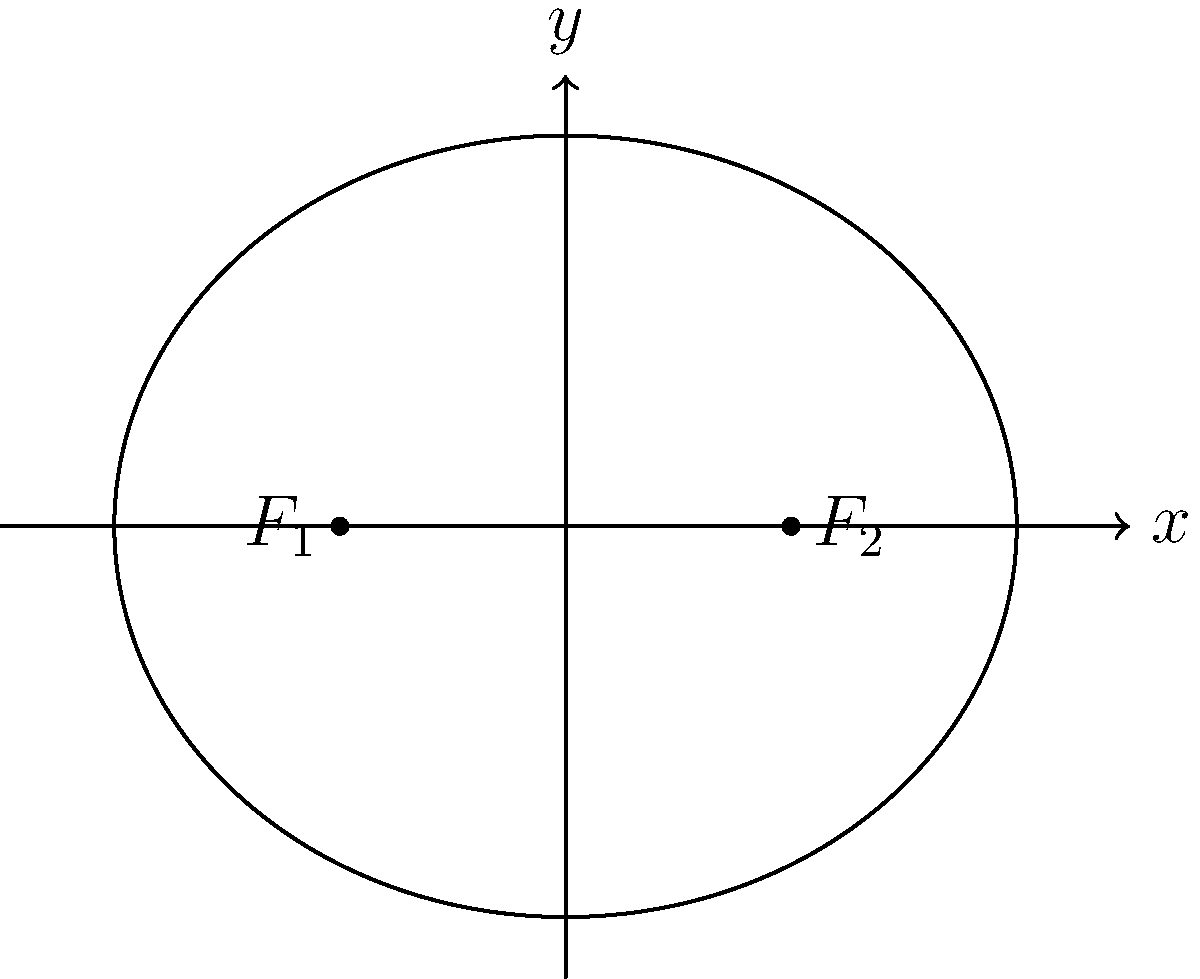As a coordinator for aid distribution, you need to determine the optimal area for distributing supplies. The distribution area is modeled by an ellipse with foci at $(-2,0)$ and $(2,0)$, and a semi-major axis of 4 units. Calculate the area of this elliptical distribution zone to the nearest square unit. To calculate the area of the elliptical distribution zone, we'll follow these steps:

1) The general formula for the area of an ellipse is $A = \pi ab$, where $a$ is the semi-major axis and $b$ is the semi-minor axis.

2) We're given that the semi-major axis $a = 4$.

3) To find $b$, we can use the relationship between the foci, semi-major axis, and semi-minor axis in an ellipse:
   $c^2 = a^2 - b^2$, where $c$ is half the distance between the foci.

4) The distance between the foci is 4 units (from -2 to 2), so $c = 2$.

5) Substituting into the equation:
   $2^2 = 4^2 - b^2$
   $4 = 16 - b^2$
   $b^2 = 12$
   $b = \sqrt{12} = 2\sqrt{3}$

6) Now we can calculate the area:
   $A = \pi ab = \pi \cdot 4 \cdot 2\sqrt{3} = 8\pi\sqrt{3}$

7) To the nearest square unit:
   $8\pi\sqrt{3} \approx 43.53$ square units

Therefore, the area of the elliptical distribution zone is approximately 44 square units.
Answer: 44 square units 